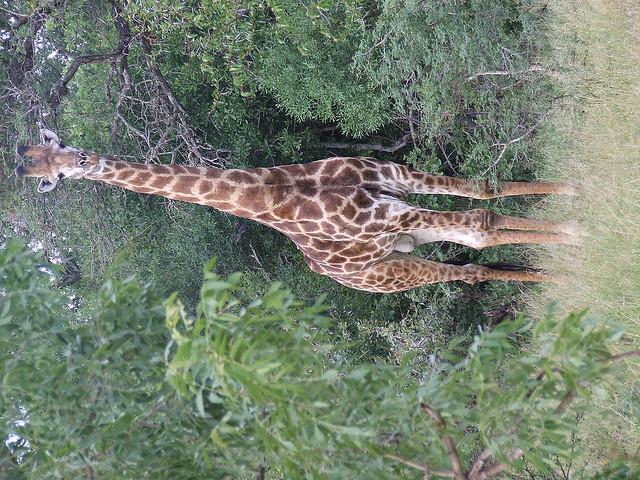What is the giraffe surrounded by?
Quick response, please. Trees. What is the giraffe looking at?
Keep it brief. Camera. Can you determine the sex of the giraffe?
Answer briefly. Yes. 